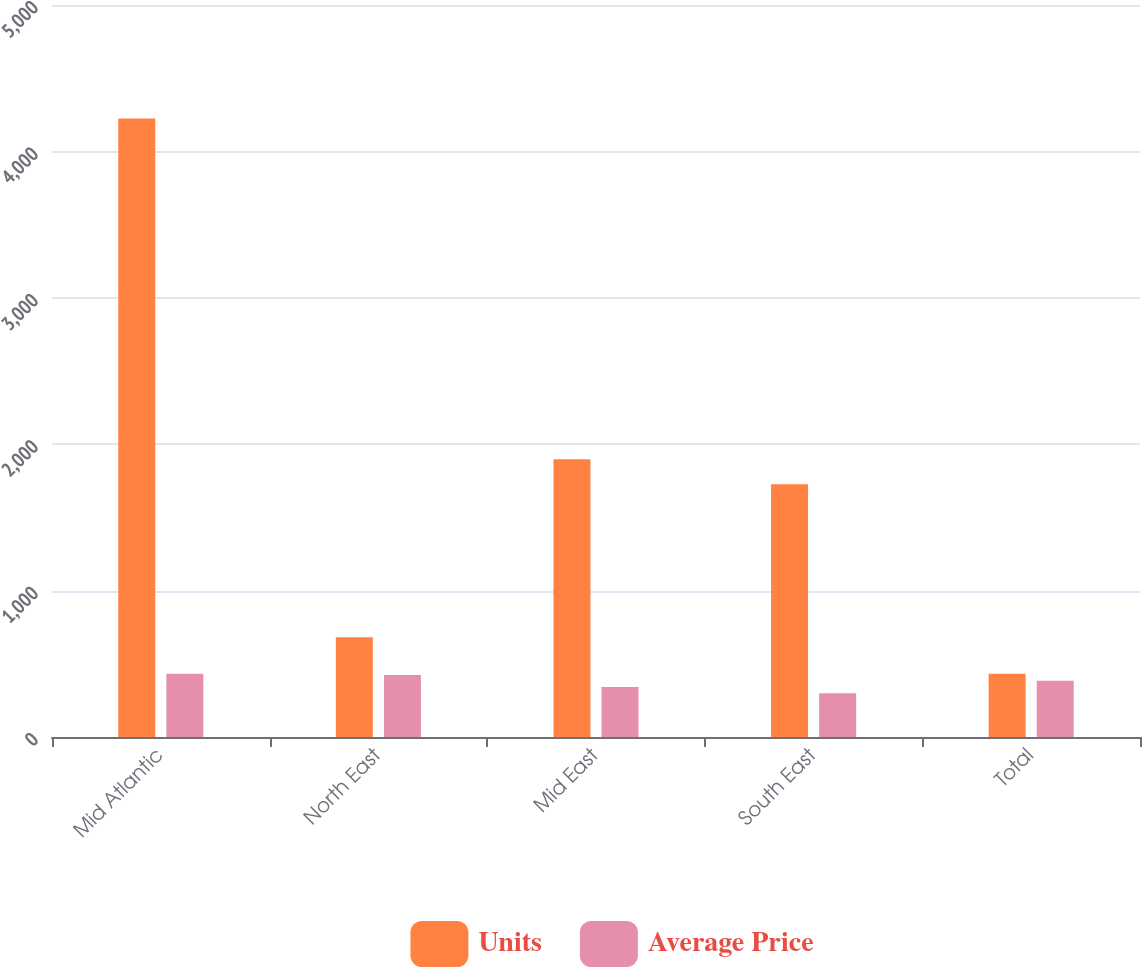Convert chart to OTSL. <chart><loc_0><loc_0><loc_500><loc_500><stacked_bar_chart><ecel><fcel>Mid Atlantic<fcel>North East<fcel>Mid East<fcel>South East<fcel>Total<nl><fcel>Units<fcel>4224<fcel>682<fcel>1898<fcel>1727<fcel>432.2<nl><fcel>Average Price<fcel>432.2<fcel>424.3<fcel>341.2<fcel>298.4<fcel>384.2<nl></chart> 